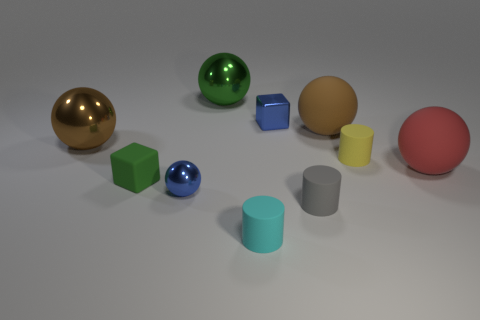Do the big thing that is behind the big brown rubber object and the green rubber object have the same shape?
Your answer should be compact. No. How many balls are behind the tiny matte cube and in front of the yellow cylinder?
Ensure brevity in your answer.  1. What is the material of the small yellow cylinder?
Offer a very short reply. Rubber. Is there anything else of the same color as the small sphere?
Provide a succinct answer. Yes. Are the red sphere and the blue cube made of the same material?
Keep it short and to the point. No. There is a large thing that is left of the blue metal thing that is in front of the red object; how many large brown metallic balls are on the left side of it?
Make the answer very short. 0. What number of large red matte objects are there?
Make the answer very short. 1. Are there fewer green matte things that are in front of the gray rubber cylinder than tiny rubber things that are on the left side of the small yellow rubber cylinder?
Your answer should be compact. Yes. Is the number of brown metal objects left of the tiny matte block less than the number of large brown spheres?
Offer a terse response. Yes. What is the material of the brown sphere that is on the left side of the tiny blue metal object in front of the matte thing to the right of the yellow rubber thing?
Keep it short and to the point. Metal. 